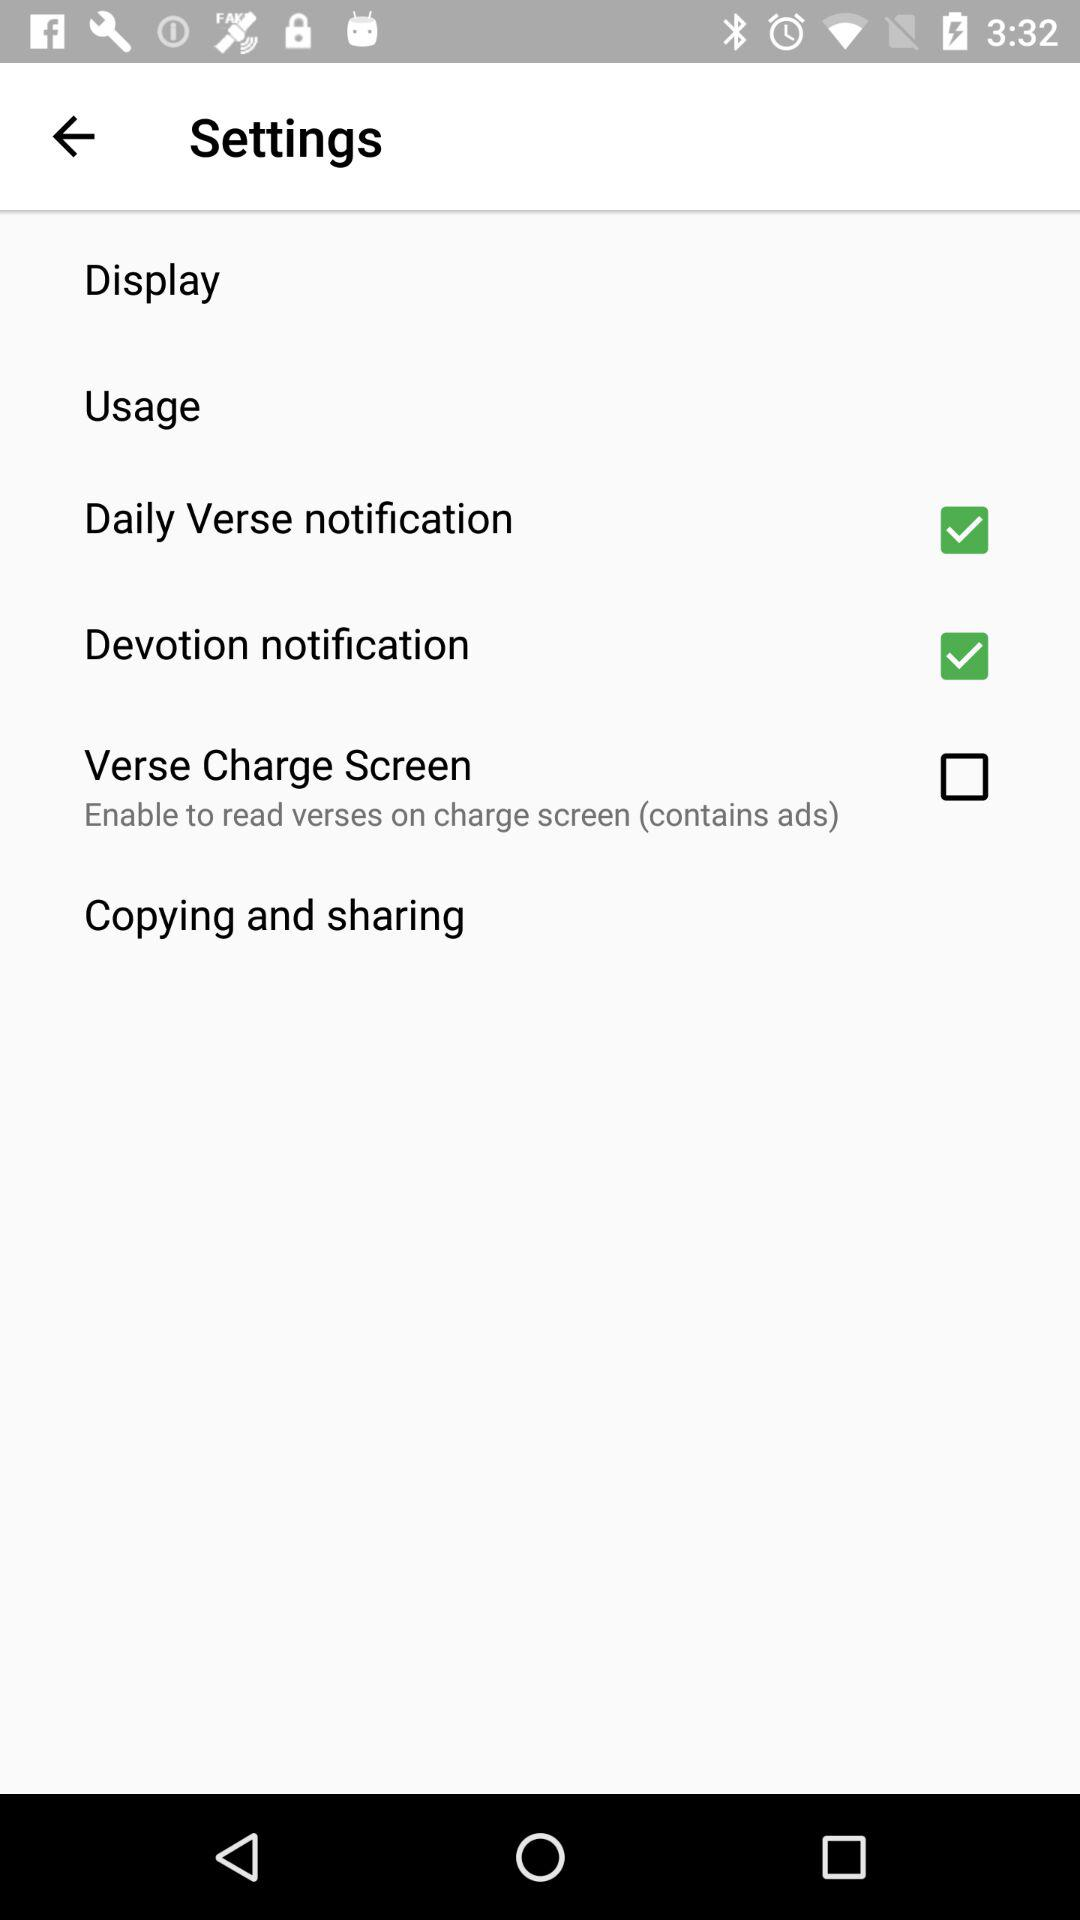What is the status of the "Devotion notification"? The status is "on". 